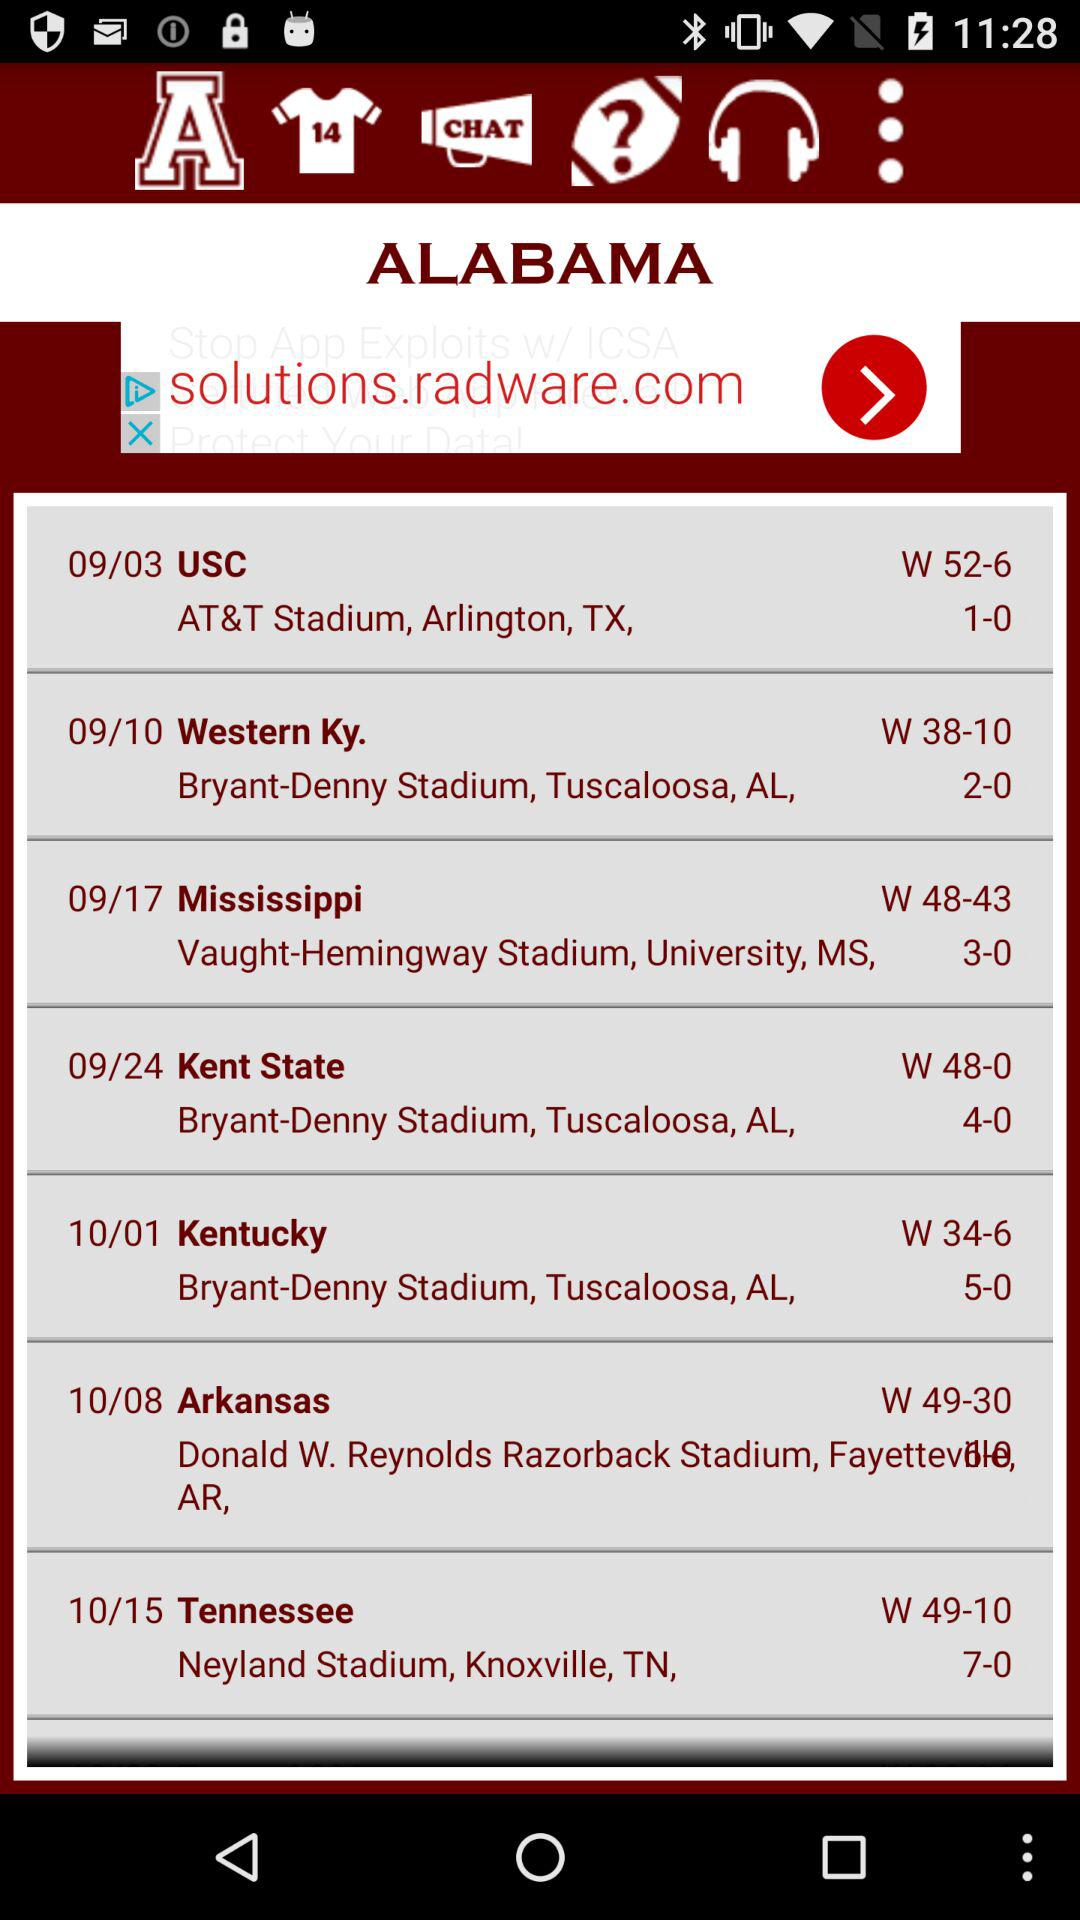How many games have Alabama won?
Answer the question using a single word or phrase. 7 